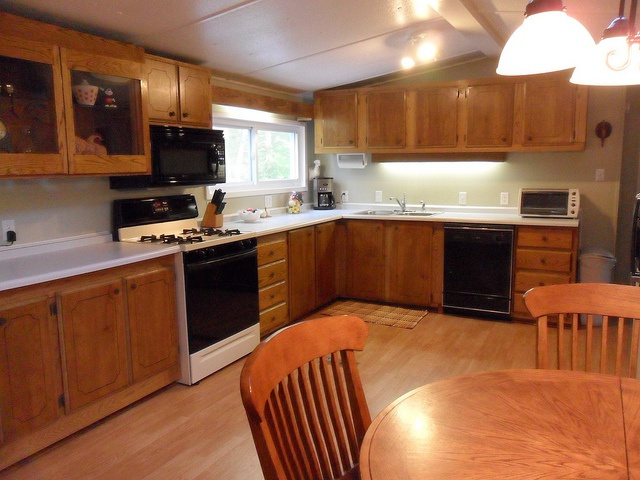Describe the objects in this image and their specific colors. I can see dining table in black, red, tan, and salmon tones, chair in black, maroon, brown, and red tones, oven in black, tan, and gray tones, chair in black, brown, red, maroon, and salmon tones, and microwave in black, gray, maroon, and darkgray tones in this image. 